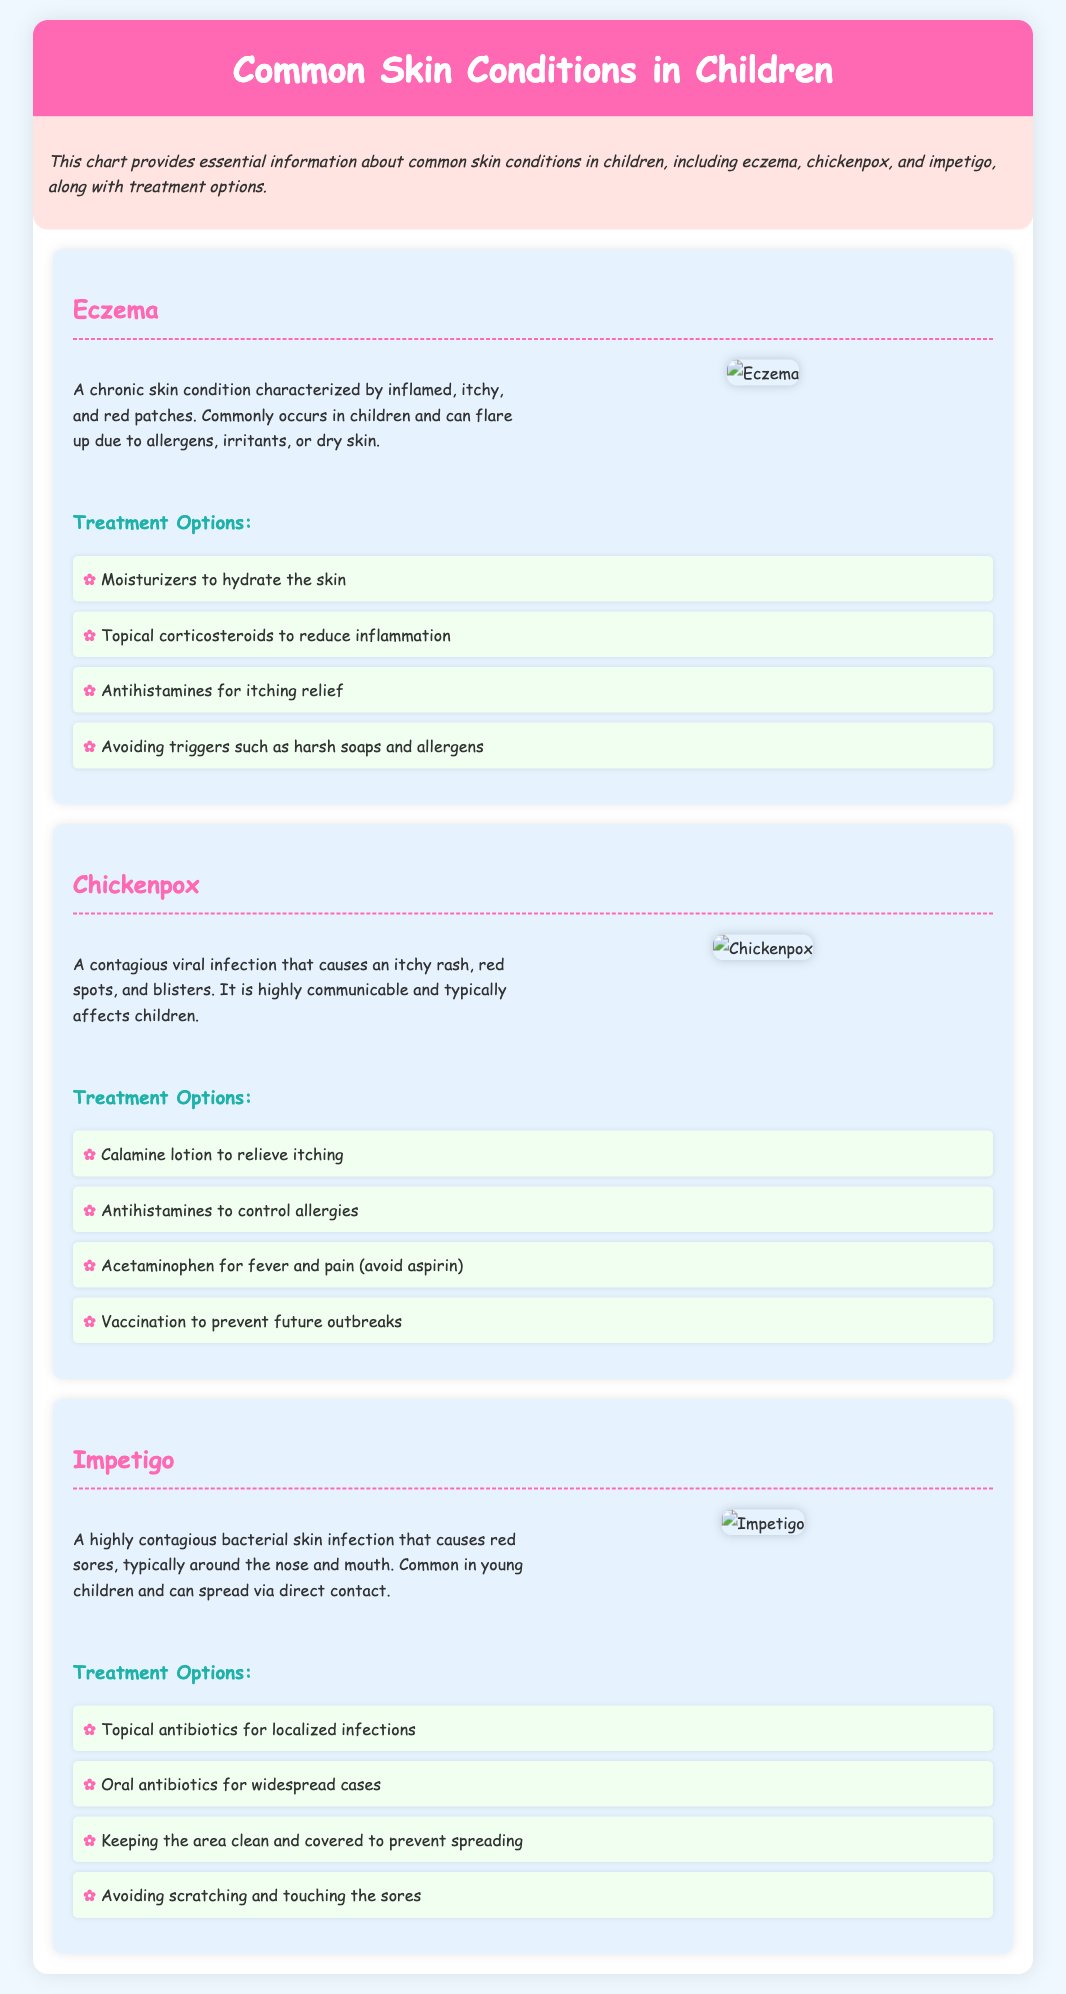What are the three skin conditions discussed? The document specifically mentions eczema, chickenpox, and impetigo as the three skin conditions.
Answer: eczema, chickenpox, impetigo What color is the background of the main title? The main title's background color is specified as pink in the document.
Answer: pink What treatment is suggested for itching relief in chickenpox? The document lists calamine lotion as a treatment for alleviating itching in chickenpox.
Answer: calamine lotion Which skin condition is described as highly contagious? The description clearly states that impetigo is a highly contagious bacterial skin infection.
Answer: impetigo How many treatment options are provided for eczema? The document outlines four treatment options for eczema, as listed under the treatment section.
Answer: four What is a common symptom of chickenpox? The document describes an itchy rash as a common symptom of chickenpox.
Answer: itchy rash What should be avoided when treating fever and pain in chickenpox? The document explicitly advises against using aspirin when treating fever and pain in chickenpox.
Answer: aspirin What type of infection causes impetigo? The document categorizes impetigo as a bacterial skin infection.
Answer: bacterial skin infection What is recommended to prevent spreading impetigo? The document suggests keeping the area clean and covered to avoid spreading impetigo.
Answer: keeping the area clean and covered 